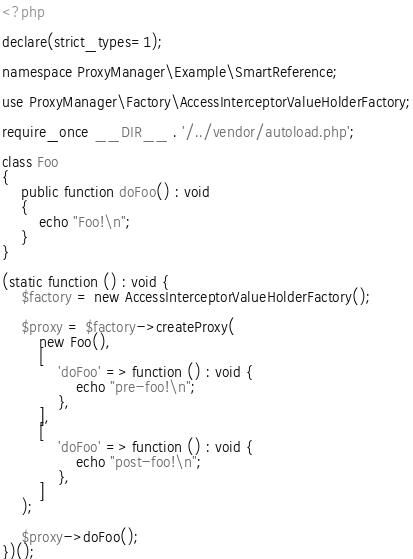Convert code to text. <code><loc_0><loc_0><loc_500><loc_500><_PHP_><?php

declare(strict_types=1);

namespace ProxyManager\Example\SmartReference;

use ProxyManager\Factory\AccessInterceptorValueHolderFactory;

require_once __DIR__ . '/../vendor/autoload.php';

class Foo
{
    public function doFoo() : void
    {
        echo "Foo!\n";
    }
}

(static function () : void {
    $factory = new AccessInterceptorValueHolderFactory();

    $proxy = $factory->createProxy(
        new Foo(),
        [
            'doFoo' => function () : void {
                echo "pre-foo!\n";
            },
        ],
        [
            'doFoo' => function () : void {
                echo "post-foo!\n";
            },
        ]
    );

    $proxy->doFoo();
})();
</code> 